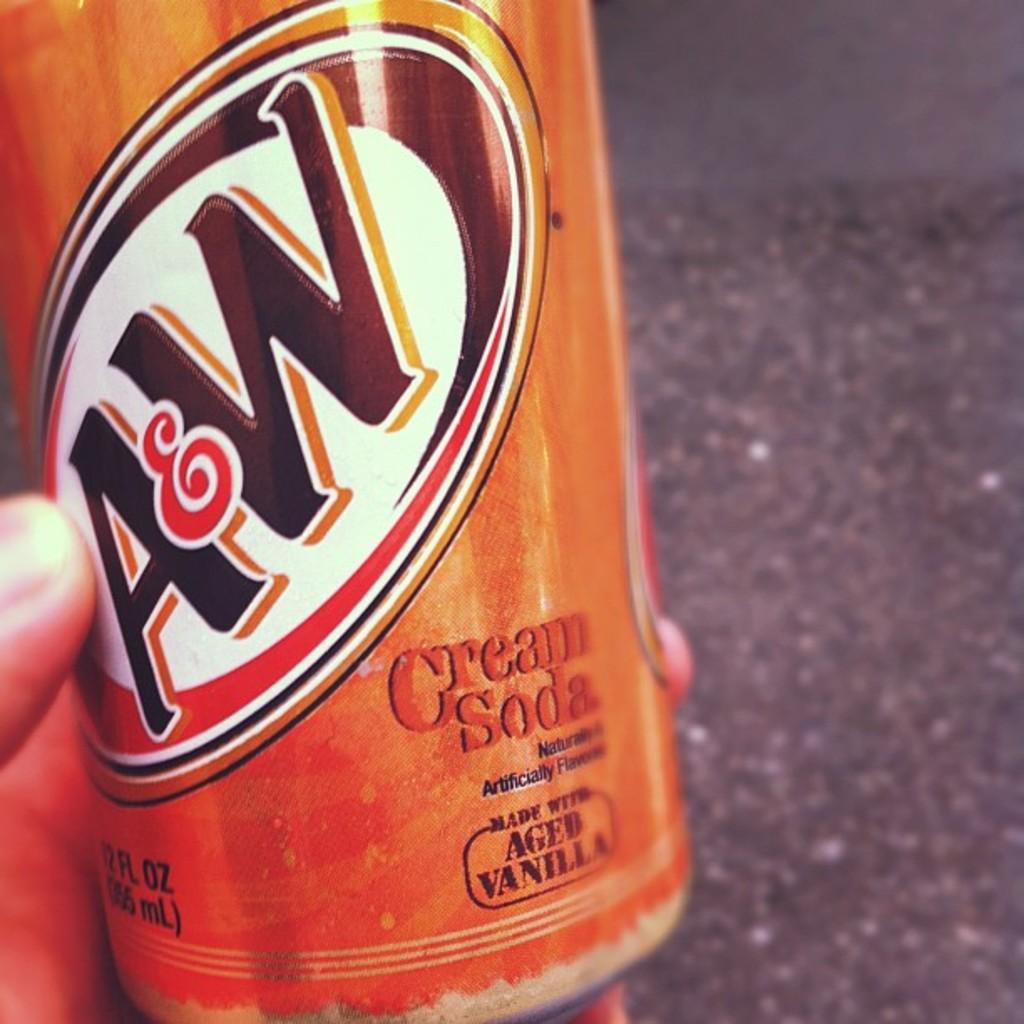<image>
Share a concise interpretation of the image provided. A&W's Cream Soda is made with aged vanilla and comes in an orange can. 